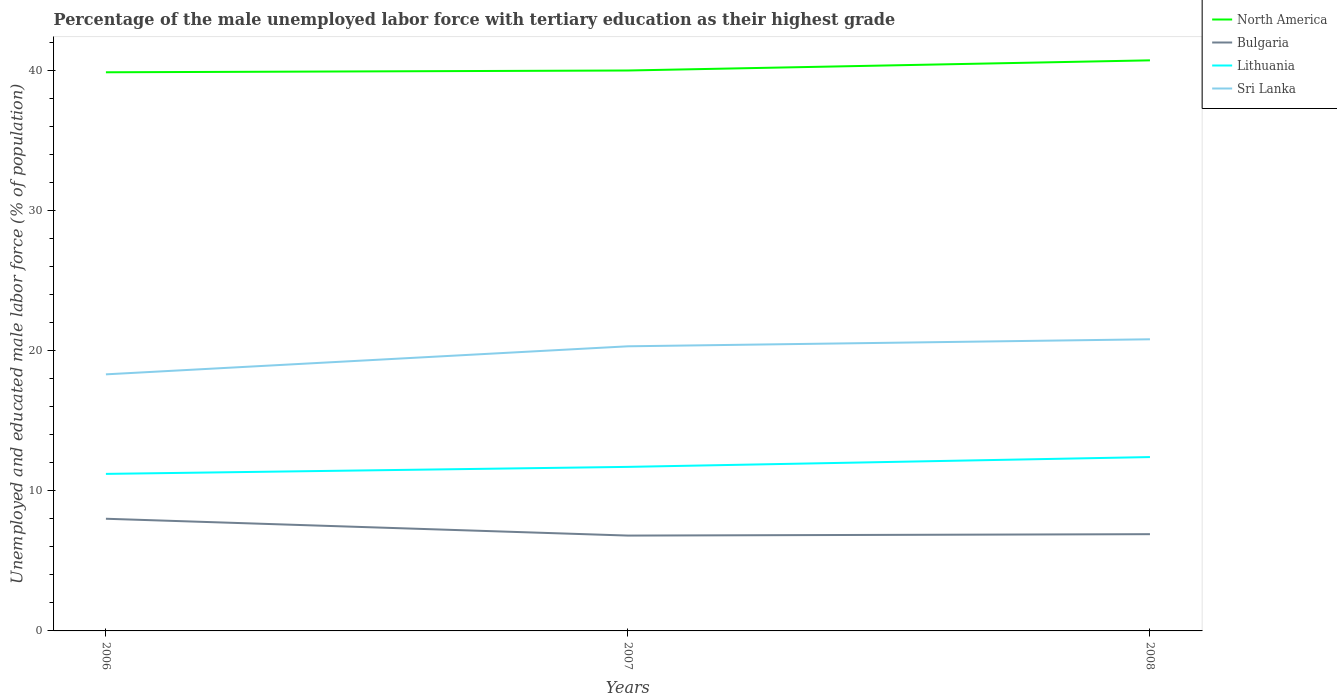How many different coloured lines are there?
Your answer should be very brief. 4. Across all years, what is the maximum percentage of the unemployed male labor force with tertiary education in Sri Lanka?
Provide a succinct answer. 18.3. In which year was the percentage of the unemployed male labor force with tertiary education in Bulgaria maximum?
Provide a short and direct response. 2007. What is the total percentage of the unemployed male labor force with tertiary education in North America in the graph?
Keep it short and to the point. -0.73. How many lines are there?
Provide a succinct answer. 4. How many years are there in the graph?
Your answer should be very brief. 3. What is the title of the graph?
Keep it short and to the point. Percentage of the male unemployed labor force with tertiary education as their highest grade. Does "Small states" appear as one of the legend labels in the graph?
Make the answer very short. No. What is the label or title of the Y-axis?
Your response must be concise. Unemployed and educated male labor force (% of population). What is the Unemployed and educated male labor force (% of population) of North America in 2006?
Provide a short and direct response. 39.84. What is the Unemployed and educated male labor force (% of population) of Bulgaria in 2006?
Your answer should be compact. 8. What is the Unemployed and educated male labor force (% of population) in Lithuania in 2006?
Provide a succinct answer. 11.2. What is the Unemployed and educated male labor force (% of population) in Sri Lanka in 2006?
Give a very brief answer. 18.3. What is the Unemployed and educated male labor force (% of population) in North America in 2007?
Your answer should be very brief. 39.97. What is the Unemployed and educated male labor force (% of population) of Bulgaria in 2007?
Offer a terse response. 6.8. What is the Unemployed and educated male labor force (% of population) of Lithuania in 2007?
Make the answer very short. 11.7. What is the Unemployed and educated male labor force (% of population) of Sri Lanka in 2007?
Make the answer very short. 20.3. What is the Unemployed and educated male labor force (% of population) of North America in 2008?
Your answer should be very brief. 40.7. What is the Unemployed and educated male labor force (% of population) of Bulgaria in 2008?
Your answer should be very brief. 6.9. What is the Unemployed and educated male labor force (% of population) of Lithuania in 2008?
Your answer should be very brief. 12.4. What is the Unemployed and educated male labor force (% of population) in Sri Lanka in 2008?
Make the answer very short. 20.8. Across all years, what is the maximum Unemployed and educated male labor force (% of population) in North America?
Ensure brevity in your answer.  40.7. Across all years, what is the maximum Unemployed and educated male labor force (% of population) in Lithuania?
Your answer should be compact. 12.4. Across all years, what is the maximum Unemployed and educated male labor force (% of population) of Sri Lanka?
Keep it short and to the point. 20.8. Across all years, what is the minimum Unemployed and educated male labor force (% of population) of North America?
Make the answer very short. 39.84. Across all years, what is the minimum Unemployed and educated male labor force (% of population) in Bulgaria?
Provide a short and direct response. 6.8. Across all years, what is the minimum Unemployed and educated male labor force (% of population) in Lithuania?
Offer a terse response. 11.2. Across all years, what is the minimum Unemployed and educated male labor force (% of population) of Sri Lanka?
Keep it short and to the point. 18.3. What is the total Unemployed and educated male labor force (% of population) of North America in the graph?
Ensure brevity in your answer.  120.51. What is the total Unemployed and educated male labor force (% of population) of Bulgaria in the graph?
Provide a short and direct response. 21.7. What is the total Unemployed and educated male labor force (% of population) of Lithuania in the graph?
Your response must be concise. 35.3. What is the total Unemployed and educated male labor force (% of population) in Sri Lanka in the graph?
Provide a short and direct response. 59.4. What is the difference between the Unemployed and educated male labor force (% of population) in North America in 2006 and that in 2007?
Offer a very short reply. -0.13. What is the difference between the Unemployed and educated male labor force (% of population) of Bulgaria in 2006 and that in 2007?
Your response must be concise. 1.2. What is the difference between the Unemployed and educated male labor force (% of population) of Lithuania in 2006 and that in 2007?
Provide a succinct answer. -0.5. What is the difference between the Unemployed and educated male labor force (% of population) in North America in 2006 and that in 2008?
Provide a short and direct response. -0.85. What is the difference between the Unemployed and educated male labor force (% of population) of Lithuania in 2006 and that in 2008?
Your answer should be very brief. -1.2. What is the difference between the Unemployed and educated male labor force (% of population) in North America in 2007 and that in 2008?
Offer a very short reply. -0.73. What is the difference between the Unemployed and educated male labor force (% of population) of Lithuania in 2007 and that in 2008?
Offer a terse response. -0.7. What is the difference between the Unemployed and educated male labor force (% of population) of North America in 2006 and the Unemployed and educated male labor force (% of population) of Bulgaria in 2007?
Give a very brief answer. 33.04. What is the difference between the Unemployed and educated male labor force (% of population) in North America in 2006 and the Unemployed and educated male labor force (% of population) in Lithuania in 2007?
Keep it short and to the point. 28.14. What is the difference between the Unemployed and educated male labor force (% of population) in North America in 2006 and the Unemployed and educated male labor force (% of population) in Sri Lanka in 2007?
Provide a short and direct response. 19.54. What is the difference between the Unemployed and educated male labor force (% of population) in Lithuania in 2006 and the Unemployed and educated male labor force (% of population) in Sri Lanka in 2007?
Provide a short and direct response. -9.1. What is the difference between the Unemployed and educated male labor force (% of population) of North America in 2006 and the Unemployed and educated male labor force (% of population) of Bulgaria in 2008?
Make the answer very short. 32.94. What is the difference between the Unemployed and educated male labor force (% of population) of North America in 2006 and the Unemployed and educated male labor force (% of population) of Lithuania in 2008?
Offer a very short reply. 27.44. What is the difference between the Unemployed and educated male labor force (% of population) in North America in 2006 and the Unemployed and educated male labor force (% of population) in Sri Lanka in 2008?
Your answer should be very brief. 19.04. What is the difference between the Unemployed and educated male labor force (% of population) of North America in 2007 and the Unemployed and educated male labor force (% of population) of Bulgaria in 2008?
Ensure brevity in your answer.  33.07. What is the difference between the Unemployed and educated male labor force (% of population) of North America in 2007 and the Unemployed and educated male labor force (% of population) of Lithuania in 2008?
Provide a succinct answer. 27.57. What is the difference between the Unemployed and educated male labor force (% of population) of North America in 2007 and the Unemployed and educated male labor force (% of population) of Sri Lanka in 2008?
Keep it short and to the point. 19.17. What is the difference between the Unemployed and educated male labor force (% of population) in Bulgaria in 2007 and the Unemployed and educated male labor force (% of population) in Lithuania in 2008?
Provide a succinct answer. -5.6. What is the difference between the Unemployed and educated male labor force (% of population) of Bulgaria in 2007 and the Unemployed and educated male labor force (% of population) of Sri Lanka in 2008?
Offer a very short reply. -14. What is the difference between the Unemployed and educated male labor force (% of population) of Lithuania in 2007 and the Unemployed and educated male labor force (% of population) of Sri Lanka in 2008?
Give a very brief answer. -9.1. What is the average Unemployed and educated male labor force (% of population) in North America per year?
Provide a succinct answer. 40.17. What is the average Unemployed and educated male labor force (% of population) in Bulgaria per year?
Give a very brief answer. 7.23. What is the average Unemployed and educated male labor force (% of population) in Lithuania per year?
Keep it short and to the point. 11.77. What is the average Unemployed and educated male labor force (% of population) in Sri Lanka per year?
Make the answer very short. 19.8. In the year 2006, what is the difference between the Unemployed and educated male labor force (% of population) in North America and Unemployed and educated male labor force (% of population) in Bulgaria?
Offer a very short reply. 31.84. In the year 2006, what is the difference between the Unemployed and educated male labor force (% of population) in North America and Unemployed and educated male labor force (% of population) in Lithuania?
Offer a terse response. 28.64. In the year 2006, what is the difference between the Unemployed and educated male labor force (% of population) in North America and Unemployed and educated male labor force (% of population) in Sri Lanka?
Your answer should be compact. 21.54. In the year 2006, what is the difference between the Unemployed and educated male labor force (% of population) of Bulgaria and Unemployed and educated male labor force (% of population) of Lithuania?
Make the answer very short. -3.2. In the year 2006, what is the difference between the Unemployed and educated male labor force (% of population) in Lithuania and Unemployed and educated male labor force (% of population) in Sri Lanka?
Offer a terse response. -7.1. In the year 2007, what is the difference between the Unemployed and educated male labor force (% of population) in North America and Unemployed and educated male labor force (% of population) in Bulgaria?
Provide a succinct answer. 33.17. In the year 2007, what is the difference between the Unemployed and educated male labor force (% of population) in North America and Unemployed and educated male labor force (% of population) in Lithuania?
Ensure brevity in your answer.  28.27. In the year 2007, what is the difference between the Unemployed and educated male labor force (% of population) in North America and Unemployed and educated male labor force (% of population) in Sri Lanka?
Your answer should be compact. 19.67. In the year 2007, what is the difference between the Unemployed and educated male labor force (% of population) in Bulgaria and Unemployed and educated male labor force (% of population) in Sri Lanka?
Your answer should be compact. -13.5. In the year 2008, what is the difference between the Unemployed and educated male labor force (% of population) in North America and Unemployed and educated male labor force (% of population) in Bulgaria?
Give a very brief answer. 33.8. In the year 2008, what is the difference between the Unemployed and educated male labor force (% of population) in North America and Unemployed and educated male labor force (% of population) in Lithuania?
Keep it short and to the point. 28.3. In the year 2008, what is the difference between the Unemployed and educated male labor force (% of population) of North America and Unemployed and educated male labor force (% of population) of Sri Lanka?
Your answer should be very brief. 19.9. In the year 2008, what is the difference between the Unemployed and educated male labor force (% of population) of Bulgaria and Unemployed and educated male labor force (% of population) of Lithuania?
Provide a short and direct response. -5.5. What is the ratio of the Unemployed and educated male labor force (% of population) of Bulgaria in 2006 to that in 2007?
Keep it short and to the point. 1.18. What is the ratio of the Unemployed and educated male labor force (% of population) in Lithuania in 2006 to that in 2007?
Make the answer very short. 0.96. What is the ratio of the Unemployed and educated male labor force (% of population) of Sri Lanka in 2006 to that in 2007?
Provide a succinct answer. 0.9. What is the ratio of the Unemployed and educated male labor force (% of population) in North America in 2006 to that in 2008?
Your answer should be compact. 0.98. What is the ratio of the Unemployed and educated male labor force (% of population) in Bulgaria in 2006 to that in 2008?
Provide a succinct answer. 1.16. What is the ratio of the Unemployed and educated male labor force (% of population) in Lithuania in 2006 to that in 2008?
Ensure brevity in your answer.  0.9. What is the ratio of the Unemployed and educated male labor force (% of population) in Sri Lanka in 2006 to that in 2008?
Offer a terse response. 0.88. What is the ratio of the Unemployed and educated male labor force (% of population) of North America in 2007 to that in 2008?
Provide a succinct answer. 0.98. What is the ratio of the Unemployed and educated male labor force (% of population) in Bulgaria in 2007 to that in 2008?
Offer a terse response. 0.99. What is the ratio of the Unemployed and educated male labor force (% of population) in Lithuania in 2007 to that in 2008?
Ensure brevity in your answer.  0.94. What is the ratio of the Unemployed and educated male labor force (% of population) of Sri Lanka in 2007 to that in 2008?
Provide a short and direct response. 0.98. What is the difference between the highest and the second highest Unemployed and educated male labor force (% of population) of North America?
Your answer should be compact. 0.73. What is the difference between the highest and the second highest Unemployed and educated male labor force (% of population) in Lithuania?
Your answer should be compact. 0.7. What is the difference between the highest and the second highest Unemployed and educated male labor force (% of population) in Sri Lanka?
Your response must be concise. 0.5. What is the difference between the highest and the lowest Unemployed and educated male labor force (% of population) of North America?
Offer a terse response. 0.85. 